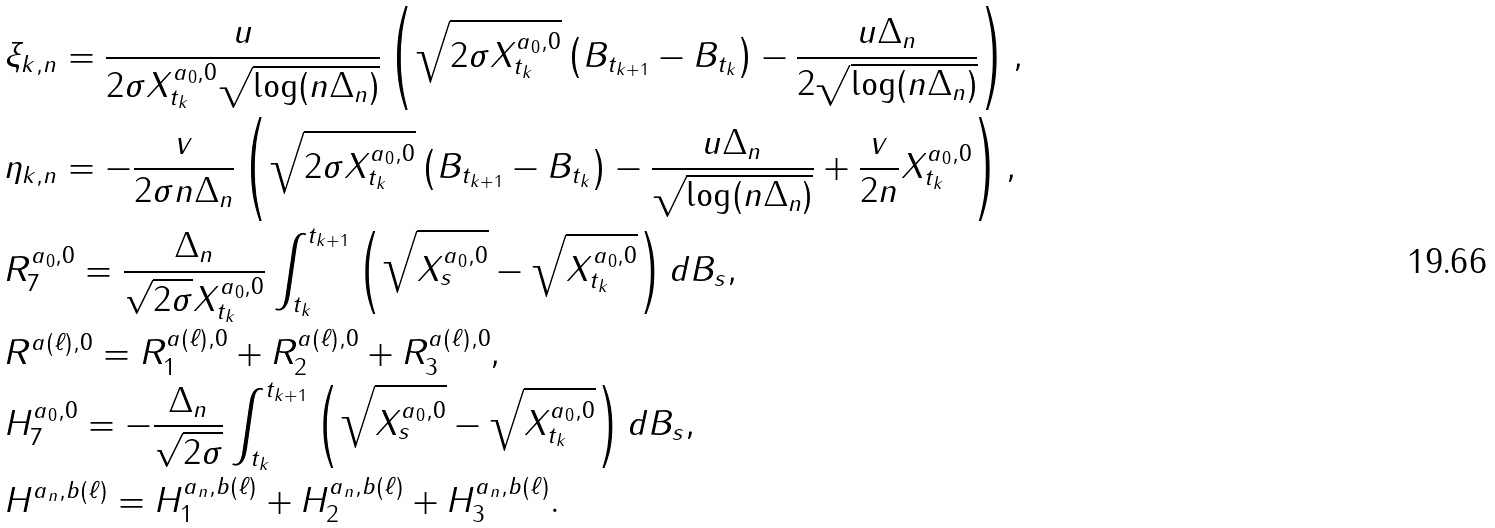Convert formula to latex. <formula><loc_0><loc_0><loc_500><loc_500>& \xi _ { k , n } = \frac { u } { 2 \sigma X _ { t _ { k } } ^ { a _ { 0 } , 0 } \sqrt { \log ( n \Delta _ { n } ) } } \left ( \sqrt { 2 \sigma X _ { t _ { k } } ^ { a _ { 0 } , 0 } } \left ( B _ { t _ { k + 1 } } - B _ { t _ { k } } \right ) - \frac { u \Delta _ { n } } { 2 \sqrt { \log ( n \Delta _ { n } ) } } \right ) , \\ & \eta _ { k , n } = - \frac { v } { 2 \sigma n \Delta _ { n } } \left ( \sqrt { 2 \sigma X _ { t _ { k } } ^ { a _ { 0 } , 0 } } \left ( B _ { t _ { k + 1 } } - B _ { t _ { k } } \right ) - \frac { u \Delta _ { n } } { \sqrt { \log ( n \Delta _ { n } ) } } + \frac { v } { 2 n } X _ { t _ { k } } ^ { a _ { 0 } , 0 } \right ) , \\ & R _ { 7 } ^ { a _ { 0 } , 0 } = \frac { \Delta _ { n } } { \sqrt { 2 \sigma } X _ { t _ { k } } ^ { a _ { 0 } , 0 } } \int _ { t _ { k } } ^ { t _ { k + 1 } } \left ( \sqrt { X _ { s } ^ { a _ { 0 } , 0 } } - \sqrt { X _ { t _ { k } } ^ { a _ { 0 } , 0 } } \right ) d B _ { s } , \\ & R ^ { a ( \ell ) , 0 } = R _ { 1 } ^ { a ( \ell ) , 0 } + R _ { 2 } ^ { a ( \ell ) , 0 } + R _ { 3 } ^ { a ( \ell ) , 0 } , \\ & H _ { 7 } ^ { a _ { 0 } , 0 } = - \frac { \Delta _ { n } } { \sqrt { 2 \sigma } } \int _ { t _ { k } } ^ { t _ { k + 1 } } \left ( \sqrt { X _ { s } ^ { a _ { 0 } , 0 } } - \sqrt { X _ { t _ { k } } ^ { a _ { 0 } , 0 } } \right ) d B _ { s } , \\ & H ^ { a _ { n } , b ( \ell ) } = H _ { 1 } ^ { a _ { n } , b ( \ell ) } + H _ { 2 } ^ { a _ { n } , b ( \ell ) } + H _ { 3 } ^ { a _ { n } , b ( \ell ) } .</formula> 